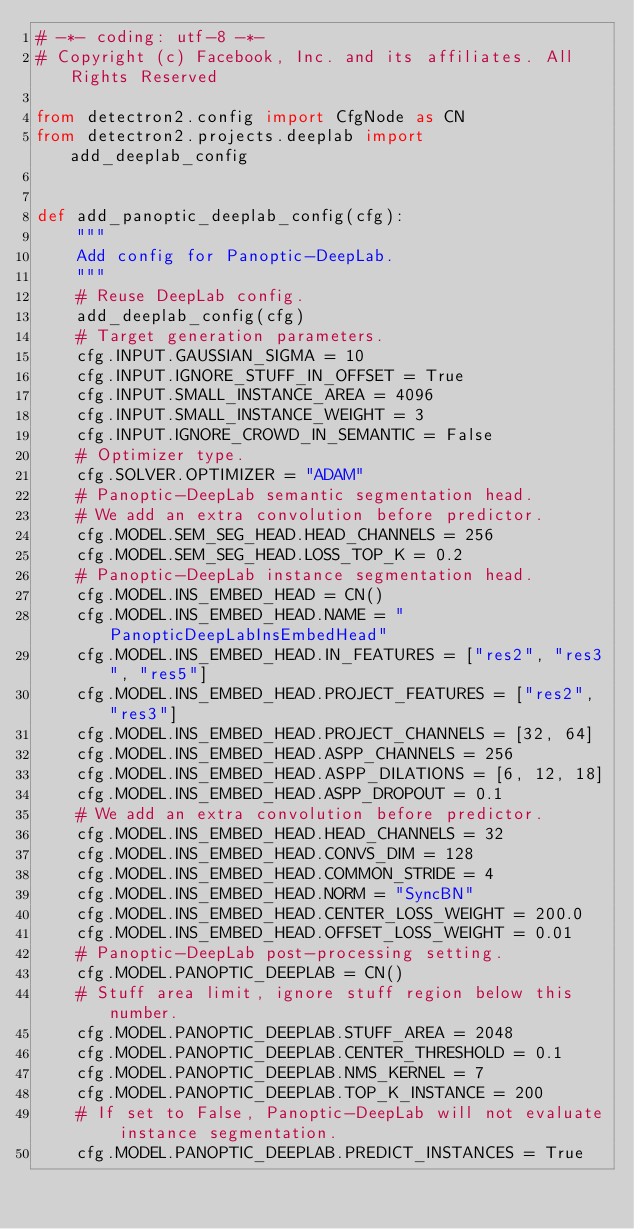Convert code to text. <code><loc_0><loc_0><loc_500><loc_500><_Python_># -*- coding: utf-8 -*-
# Copyright (c) Facebook, Inc. and its affiliates. All Rights Reserved

from detectron2.config import CfgNode as CN
from detectron2.projects.deeplab import add_deeplab_config


def add_panoptic_deeplab_config(cfg):
    """
    Add config for Panoptic-DeepLab.
    """
    # Reuse DeepLab config.
    add_deeplab_config(cfg)
    # Target generation parameters.
    cfg.INPUT.GAUSSIAN_SIGMA = 10
    cfg.INPUT.IGNORE_STUFF_IN_OFFSET = True
    cfg.INPUT.SMALL_INSTANCE_AREA = 4096
    cfg.INPUT.SMALL_INSTANCE_WEIGHT = 3
    cfg.INPUT.IGNORE_CROWD_IN_SEMANTIC = False
    # Optimizer type.
    cfg.SOLVER.OPTIMIZER = "ADAM"
    # Panoptic-DeepLab semantic segmentation head.
    # We add an extra convolution before predictor.
    cfg.MODEL.SEM_SEG_HEAD.HEAD_CHANNELS = 256
    cfg.MODEL.SEM_SEG_HEAD.LOSS_TOP_K = 0.2
    # Panoptic-DeepLab instance segmentation head.
    cfg.MODEL.INS_EMBED_HEAD = CN()
    cfg.MODEL.INS_EMBED_HEAD.NAME = "PanopticDeepLabInsEmbedHead"
    cfg.MODEL.INS_EMBED_HEAD.IN_FEATURES = ["res2", "res3", "res5"]
    cfg.MODEL.INS_EMBED_HEAD.PROJECT_FEATURES = ["res2", "res3"]
    cfg.MODEL.INS_EMBED_HEAD.PROJECT_CHANNELS = [32, 64]
    cfg.MODEL.INS_EMBED_HEAD.ASPP_CHANNELS = 256
    cfg.MODEL.INS_EMBED_HEAD.ASPP_DILATIONS = [6, 12, 18]
    cfg.MODEL.INS_EMBED_HEAD.ASPP_DROPOUT = 0.1
    # We add an extra convolution before predictor.
    cfg.MODEL.INS_EMBED_HEAD.HEAD_CHANNELS = 32
    cfg.MODEL.INS_EMBED_HEAD.CONVS_DIM = 128
    cfg.MODEL.INS_EMBED_HEAD.COMMON_STRIDE = 4
    cfg.MODEL.INS_EMBED_HEAD.NORM = "SyncBN"
    cfg.MODEL.INS_EMBED_HEAD.CENTER_LOSS_WEIGHT = 200.0
    cfg.MODEL.INS_EMBED_HEAD.OFFSET_LOSS_WEIGHT = 0.01
    # Panoptic-DeepLab post-processing setting.
    cfg.MODEL.PANOPTIC_DEEPLAB = CN()
    # Stuff area limit, ignore stuff region below this number.
    cfg.MODEL.PANOPTIC_DEEPLAB.STUFF_AREA = 2048
    cfg.MODEL.PANOPTIC_DEEPLAB.CENTER_THRESHOLD = 0.1
    cfg.MODEL.PANOPTIC_DEEPLAB.NMS_KERNEL = 7
    cfg.MODEL.PANOPTIC_DEEPLAB.TOP_K_INSTANCE = 200
    # If set to False, Panoptic-DeepLab will not evaluate instance segmentation.
    cfg.MODEL.PANOPTIC_DEEPLAB.PREDICT_INSTANCES = True
</code> 